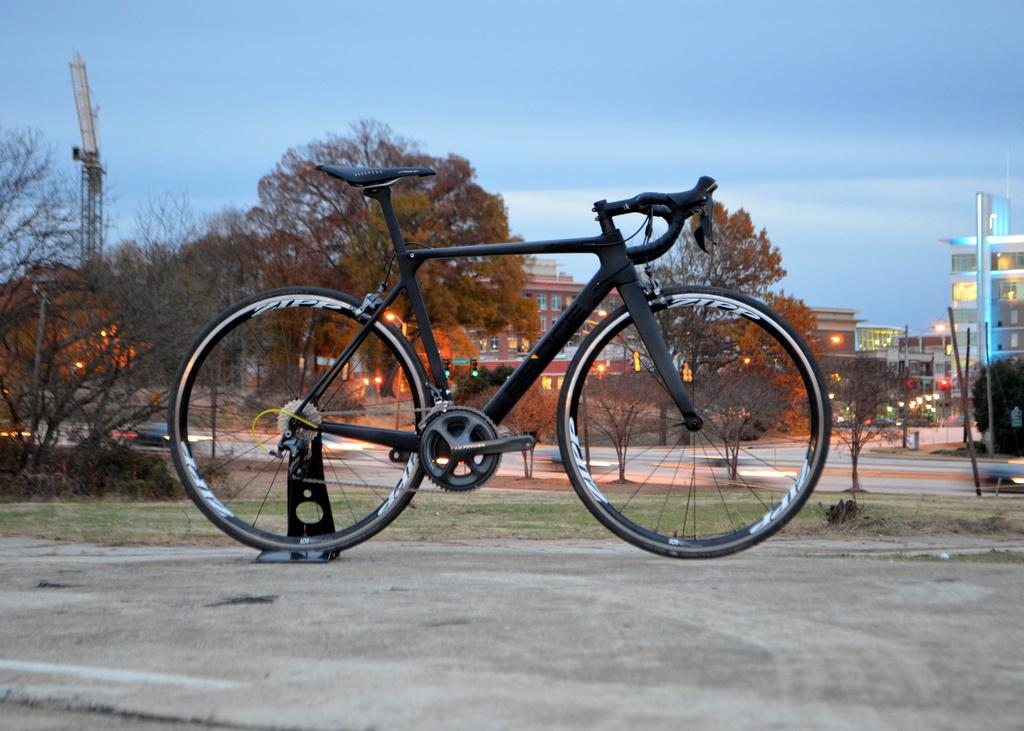What is the main object in the foreground of the image? There is a cycle on a stand in the foreground of the image. What can be seen in the background of the image? There are trees, lights, buildings, a road, and the sky visible in the background of the image. What type of rose is being used as a prop for the airplane in the image? There is no rose or airplane present in the image. Is there a picture of a famous landmark visible in the image? The image does not show a picture of a famous landmark; it features a cycle on a stand and various elements in the background. 